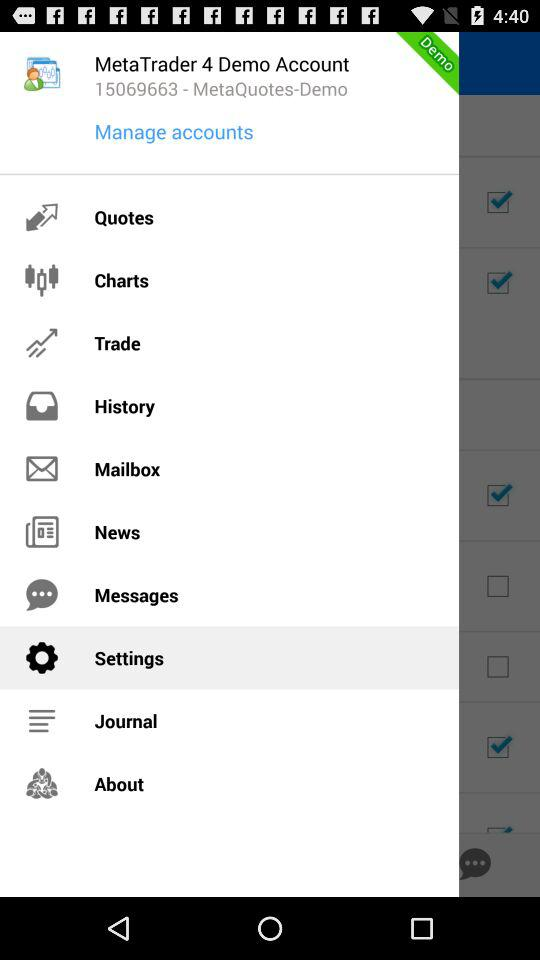What's the "MetaTrader 4" demo account number? The "MetaTrader 4" demo account number is 15069663. 